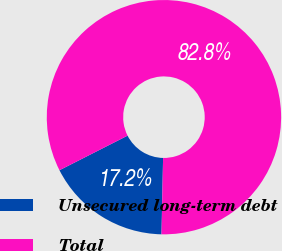Convert chart to OTSL. <chart><loc_0><loc_0><loc_500><loc_500><pie_chart><fcel>Unsecured long-term debt<fcel>Total<nl><fcel>17.19%<fcel>82.81%<nl></chart> 